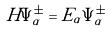Convert formula to latex. <formula><loc_0><loc_0><loc_500><loc_500>H \Psi _ { \alpha } ^ { \pm } = E _ { \alpha } \Psi _ { \alpha } ^ { \pm }</formula> 